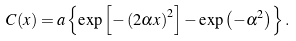Convert formula to latex. <formula><loc_0><loc_0><loc_500><loc_500>C ( x ) = a \left \{ \exp \left [ - \left ( 2 \alpha x \right ) ^ { 2 } \right ] - \exp \left ( - \alpha ^ { 2 } \right ) \right \} .</formula> 